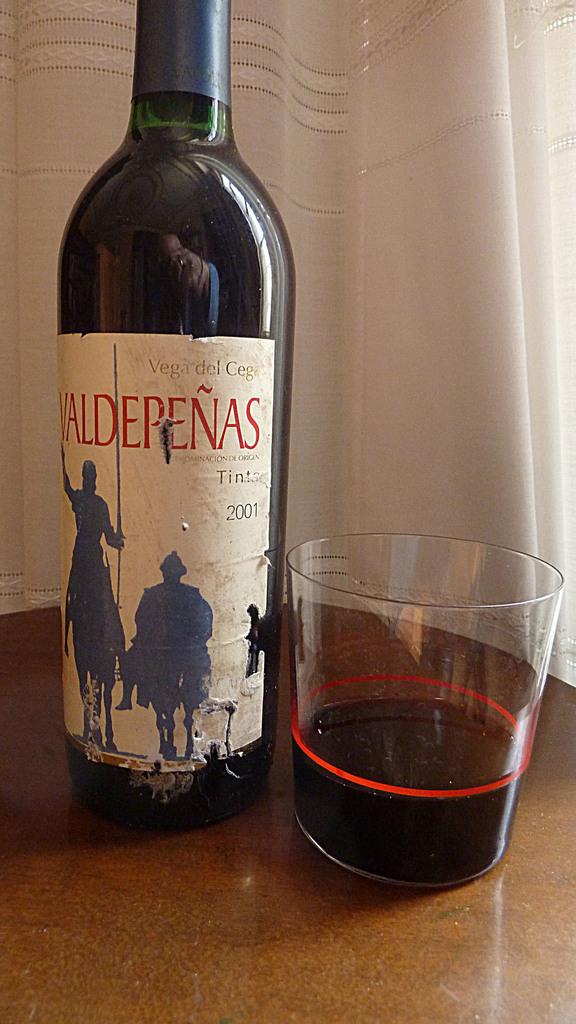What kind of wine is this?
Make the answer very short. Valdepenas. What year is on the bottle?
Make the answer very short. 2001. 